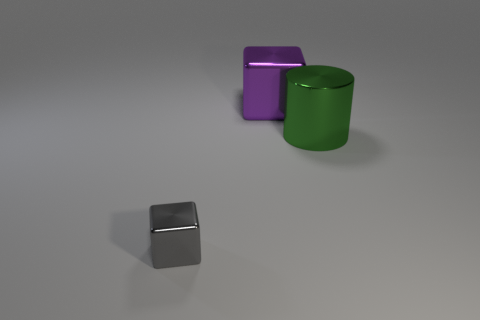What is the shape of the thing behind the thing that is on the right side of the block that is to the right of the tiny thing? cube 